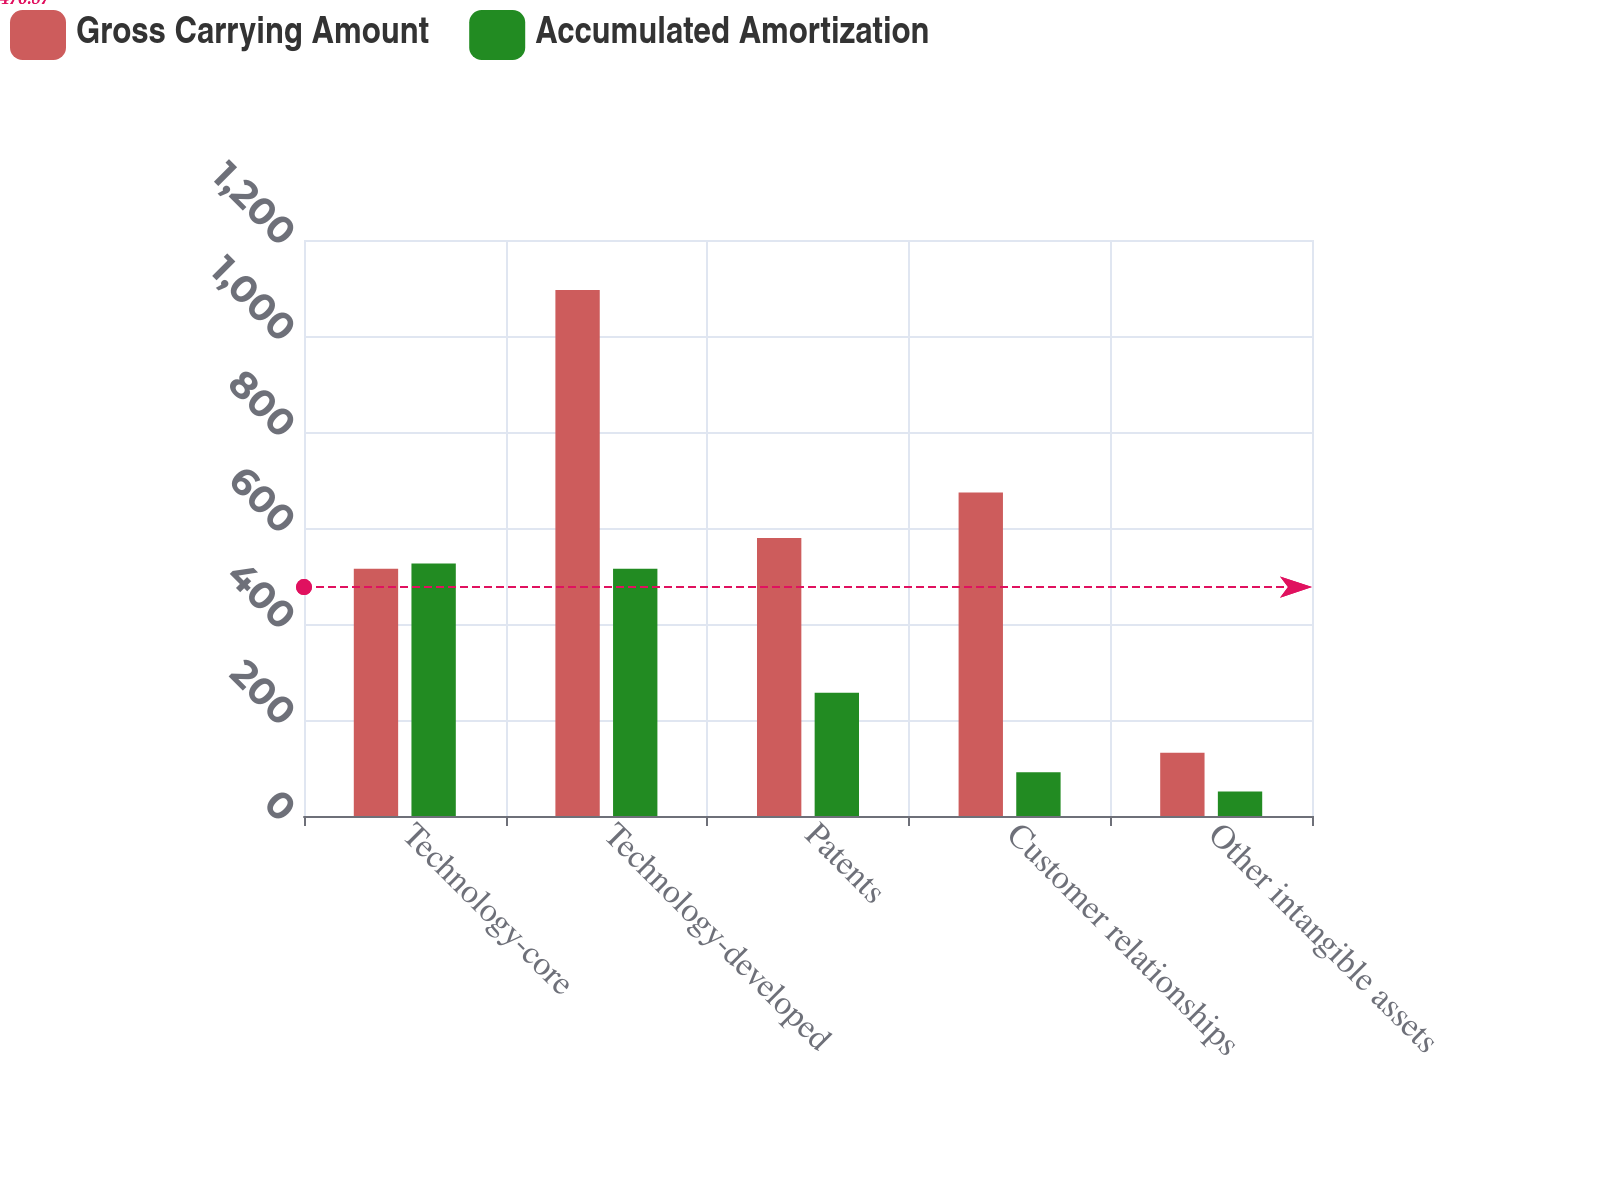Convert chart to OTSL. <chart><loc_0><loc_0><loc_500><loc_500><stacked_bar_chart><ecel><fcel>Technology-core<fcel>Technology-developed<fcel>Patents<fcel>Customer relationships<fcel>Other intangible assets<nl><fcel>Gross Carrying Amount<fcel>515<fcel>1096<fcel>579<fcel>674<fcel>132<nl><fcel>Accumulated Amortization<fcel>526<fcel>515<fcel>257<fcel>91<fcel>51<nl></chart> 